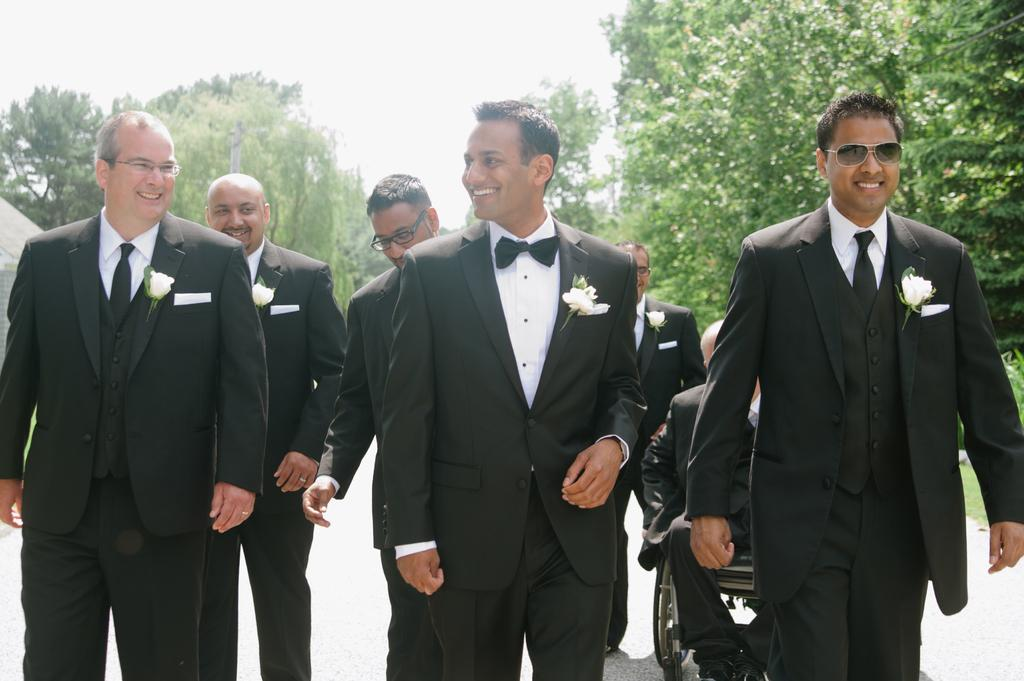How many men are in the image? There are six men in the image. What are the men wearing? The men are wearing black coats and bow ties. What can be seen on each coat? There is a white flower on each coat. What is the facial expression of the men? The men are smiling. Where are the men located in the image? The men are walking on a road. What is visible in the background of the image? There are trees in the background of the image. What is the weather like in the image? The provided facts do not mention the weather, so we cannot determine the weather from the image. What type of shock can be seen on the men's faces in the image? There is no indication of shock on the men's faces in the image; they are smiling. 